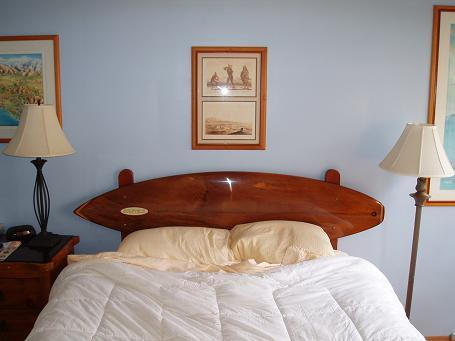Question: what is the picture?
Choices:
A. Bathroom.
B. Porch.
C. Kitchen.
D. Bedroom.
Answer with the letter. Answer: D Question: why are there lamps?
Choices:
A. For decoration.
B. For sale.
C. For fun.
D. For light.
Answer with the letter. Answer: D Question: what is the little lamp on?
Choices:
A. Dresser.
B. Floor.
C. Nightstand.
D. Counter.
Answer with the letter. Answer: C 